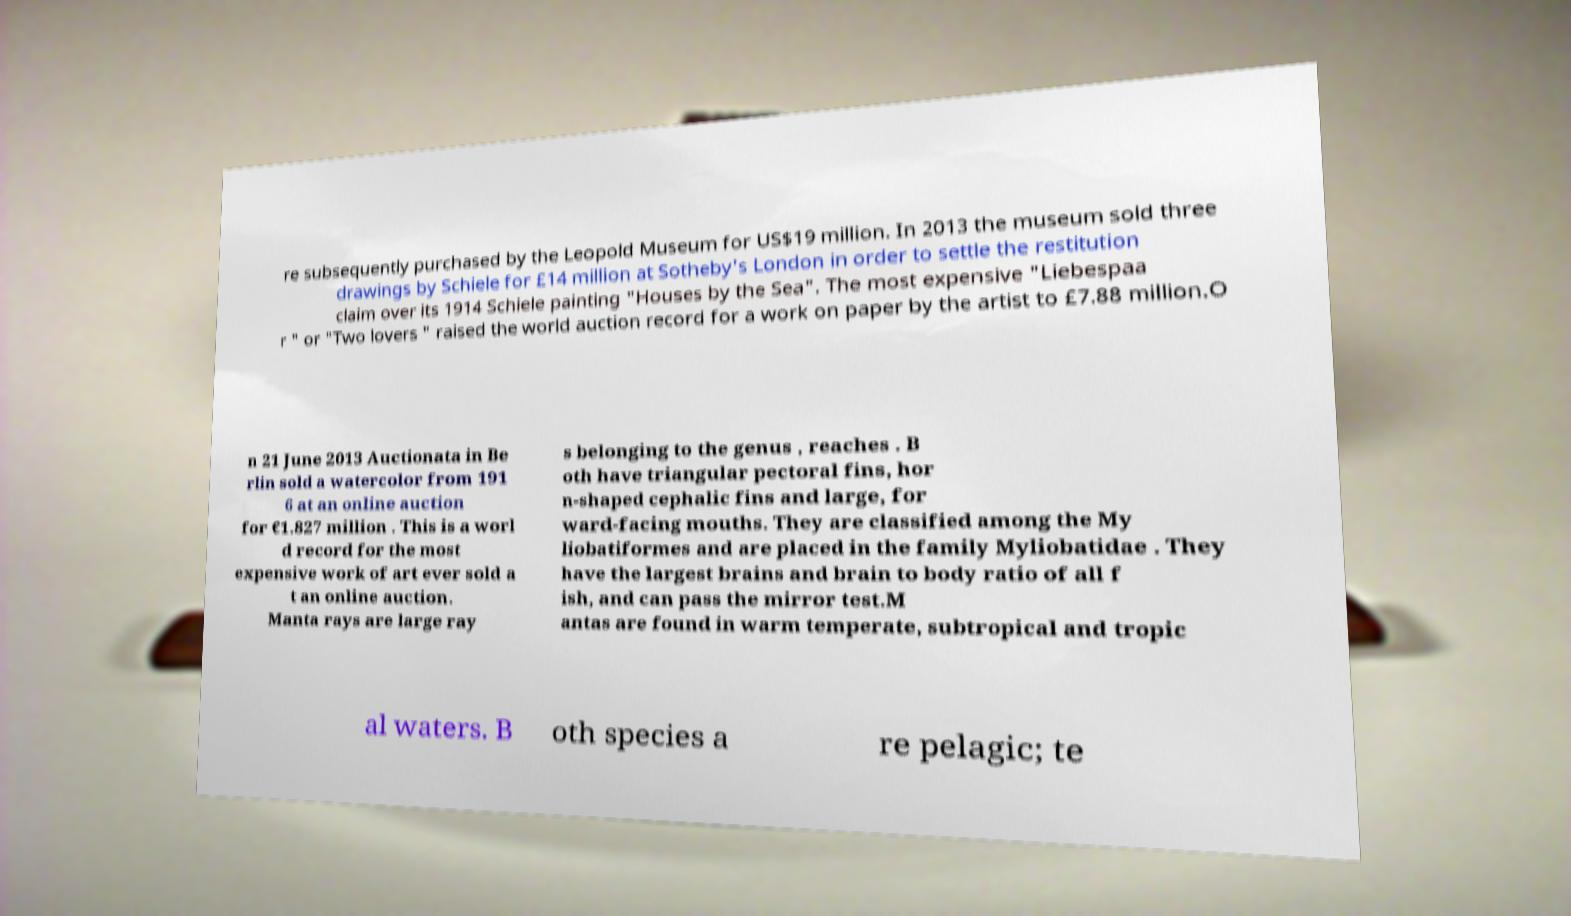I need the written content from this picture converted into text. Can you do that? re subsequently purchased by the Leopold Museum for US$19 million. In 2013 the museum sold three drawings by Schiele for £14 million at Sotheby's London in order to settle the restitution claim over its 1914 Schiele painting "Houses by the Sea". The most expensive "Liebespaa r " or "Two lovers " raised the world auction record for a work on paper by the artist to £7.88 million.O n 21 June 2013 Auctionata in Be rlin sold a watercolor from 191 6 at an online auction for €1.827 million . This is a worl d record for the most expensive work of art ever sold a t an online auction. Manta rays are large ray s belonging to the genus , reaches . B oth have triangular pectoral fins, hor n-shaped cephalic fins and large, for ward-facing mouths. They are classified among the My liobatiformes and are placed in the family Myliobatidae . They have the largest brains and brain to body ratio of all f ish, and can pass the mirror test.M antas are found in warm temperate, subtropical and tropic al waters. B oth species a re pelagic; te 